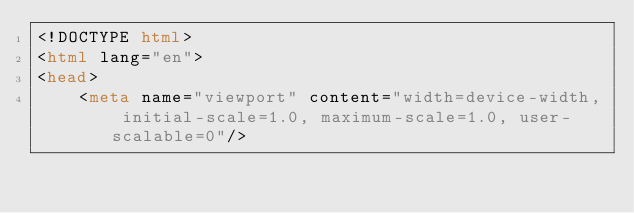Convert code to text. <code><loc_0><loc_0><loc_500><loc_500><_HTML_><!DOCTYPE html>
<html lang="en">
<head>
    <meta name="viewport" content="width=device-width, initial-scale=1.0, maximum-scale=1.0, user-scalable=0"/></code> 